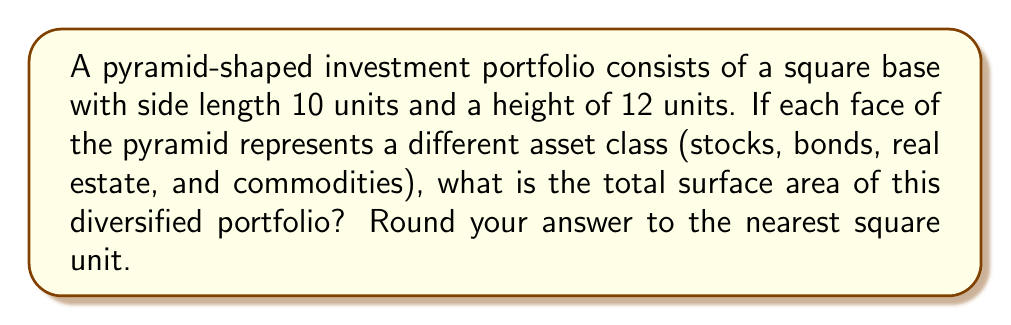Give your solution to this math problem. To find the surface area of a pyramid, we need to calculate the area of the base and the areas of the four triangular faces, then sum them up.

1. Area of the base:
   The base is a square with side length 10 units.
   $$A_{base} = s^2 = 10^2 = 100\text{ square units}$$

2. Area of a triangular face:
   We need to find the slant height (l) of the pyramid using the Pythagorean theorem:
   $$l^2 = (\frac{s}{2})^2 + h^2$$
   $$l^2 = 5^2 + 12^2 = 25 + 144 = 169$$
   $$l = \sqrt{169} = 13\text{ units}$$

   Now we can calculate the area of one triangular face:
   $$A_{face} = \frac{1}{2} \times \text{base} \times \text{height} = \frac{1}{2} \times 10 \times 13 = 65\text{ square units}$$

3. Total surface area:
   $$SA_{total} = A_{base} + 4 \times A_{face}$$
   $$SA_{total} = 100 + 4 \times 65 = 100 + 260 = 360\text{ square units}$$

This surface area represents the total exposure to different asset classes in the investment portfolio.
Answer: 360 square units 